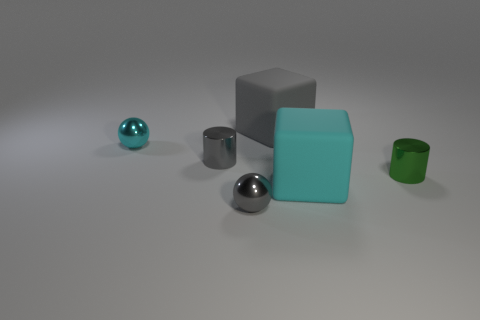How many matte objects are on the right side of the large thing that is behind the tiny shiny cylinder behind the small green shiny object?
Offer a very short reply. 1. There is a gray thing that is both left of the big gray rubber block and behind the small gray ball; what material is it?
Provide a succinct answer. Metal. Are there more cyan cubes in front of the big cyan matte cube than rubber objects that are left of the large gray object?
Your answer should be very brief. No. The metal cylinder to the left of the big gray object is what color?
Make the answer very short. Gray. Is the size of the cube left of the large cyan block the same as the metallic ball that is to the right of the cyan metallic thing?
Your answer should be very brief. No. How many objects are red metal spheres or small green cylinders?
Offer a very short reply. 1. There is a cyan object that is on the left side of the large block that is on the right side of the gray rubber thing; what is its material?
Keep it short and to the point. Metal. What number of other matte things have the same shape as the large gray thing?
Provide a succinct answer. 1. What number of things are either metallic objects that are behind the tiny green metallic object or cyan objects that are left of the tiny gray ball?
Offer a terse response. 2. There is a cyan thing on the right side of the cyan sphere; is there a cyan matte cube behind it?
Your answer should be very brief. No. 